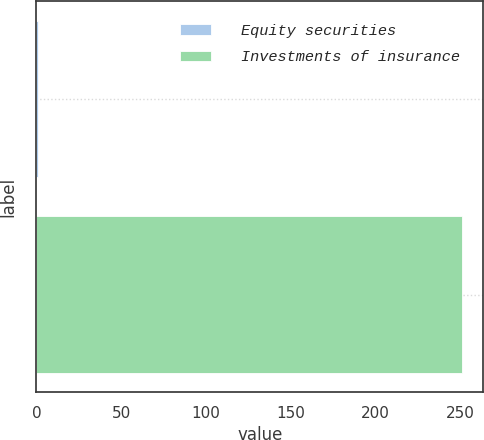<chart> <loc_0><loc_0><loc_500><loc_500><bar_chart><fcel>Equity securities<fcel>Investments of insurance<nl><fcel>1<fcel>251<nl></chart> 